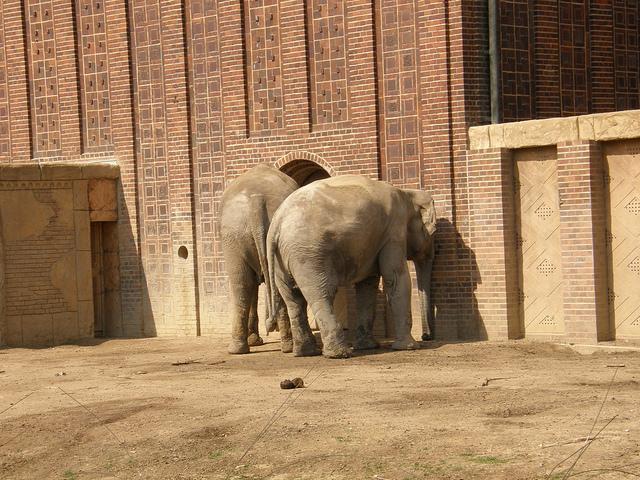How many elephants are there?
Give a very brief answer. 2. How many elephants can you see?
Give a very brief answer. 2. 